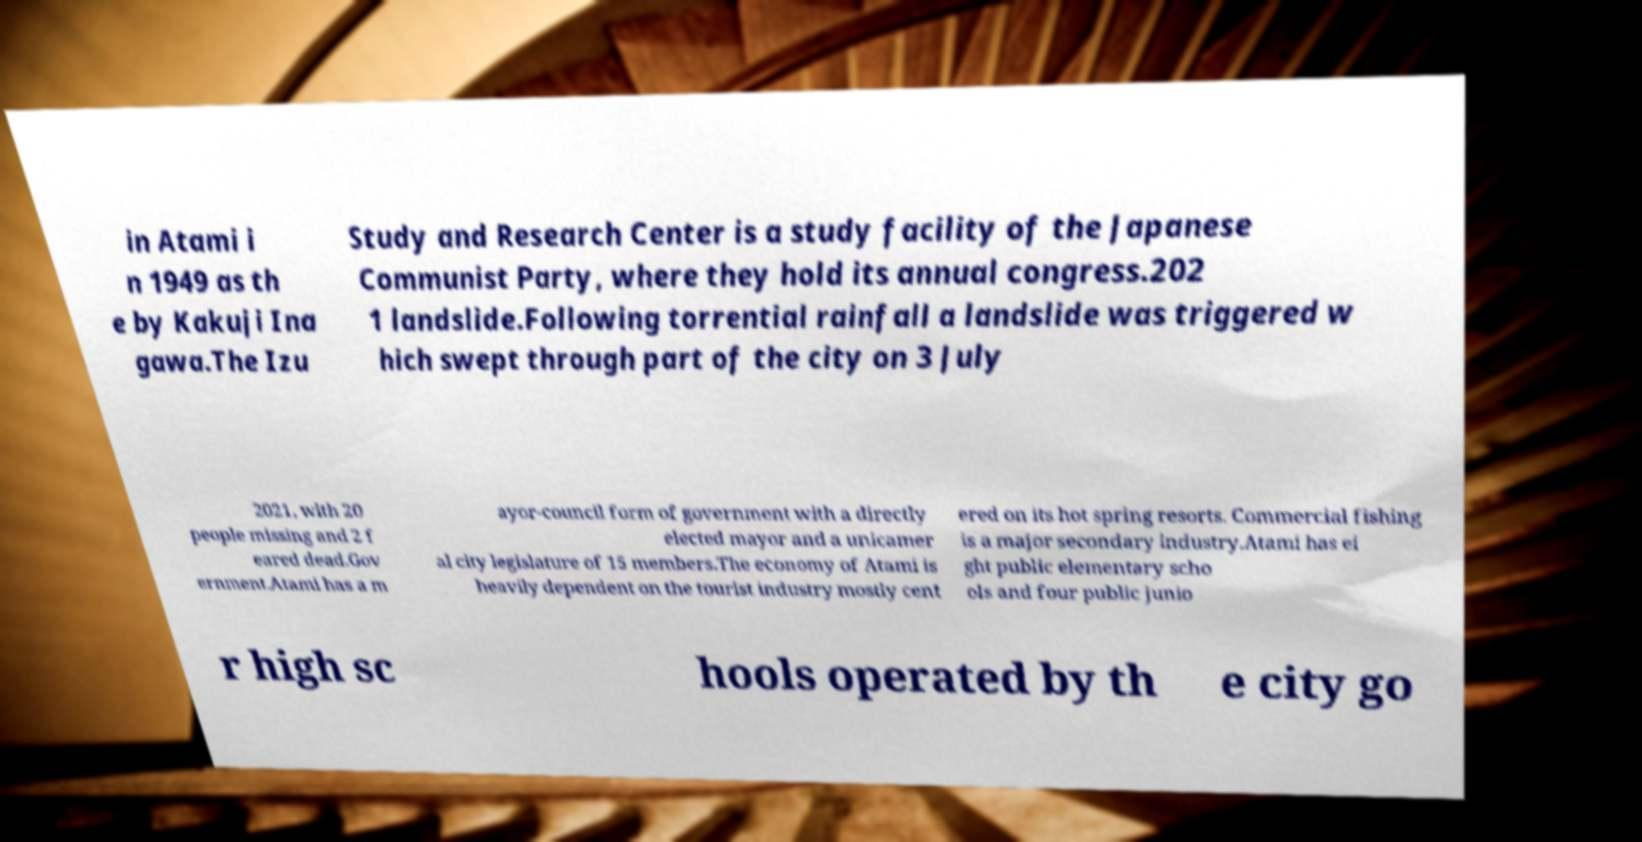There's text embedded in this image that I need extracted. Can you transcribe it verbatim? in Atami i n 1949 as th e by Kakuji Ina gawa.The Izu Study and Research Center is a study facility of the Japanese Communist Party, where they hold its annual congress.202 1 landslide.Following torrential rainfall a landslide was triggered w hich swept through part of the city on 3 July 2021, with 20 people missing and 2 f eared dead.Gov ernment.Atami has a m ayor-council form of government with a directly elected mayor and a unicamer al city legislature of 15 members.The economy of Atami is heavily dependent on the tourist industry mostly cent ered on its hot spring resorts. Commercial fishing is a major secondary industry.Atami has ei ght public elementary scho ols and four public junio r high sc hools operated by th e city go 